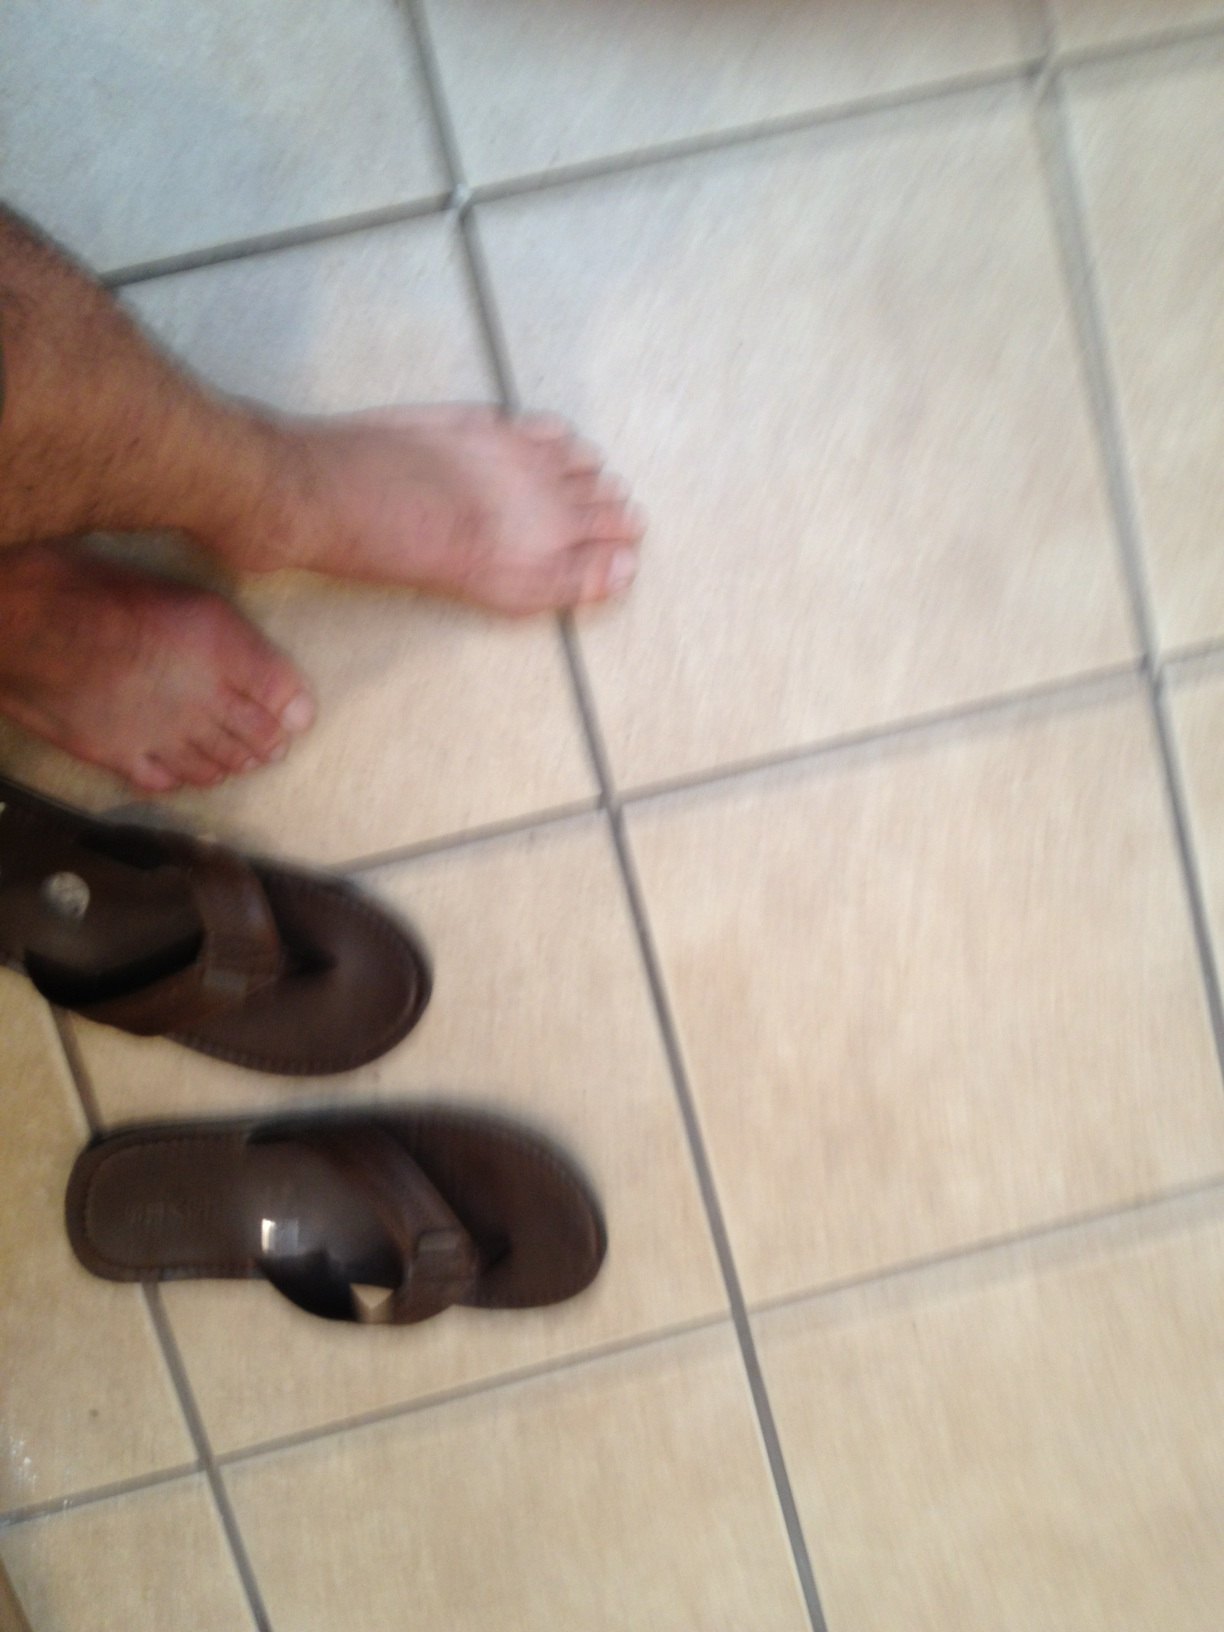What is that? The object in the image is a pair of brown flip flops, partially under a chair. This common type of footwear is designed for comfort and ease, typically worn in casual settings. 